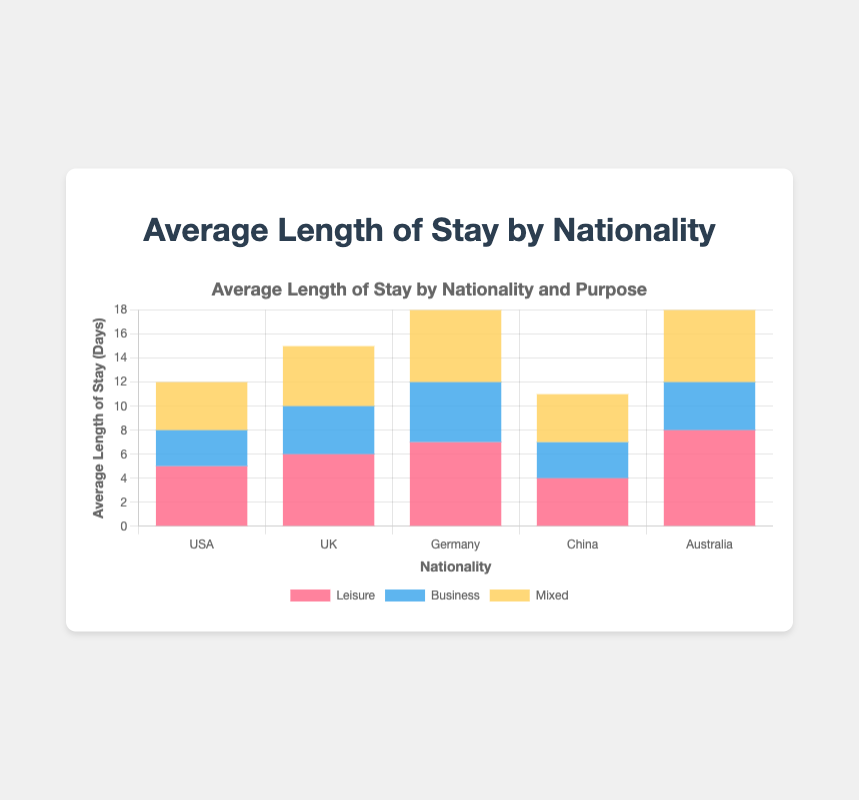What is the average length of stay for leisure purposes across all nationalities? Sum the leisure lengths for all nationalities: (5+6+7+4+8) = 30, then divide by the number of nationalities: 30/5 = 6
Answer: 6 Which nationality has the highest average length of stay for business purposes? Identify the heights of the blue bars representing business purposes; Germany has the highest value at 5 days
Answer: Germany Which nationality has the lowest average length of stay for mixed purposes? Identify the heights of the yellow bars representing mixed purposes; USA and China both have the lowest at 4 days
Answer: USA and China How much longer is the average length of stay for leisure compared to business for Australian tourists? Subtract Australia's business length (4 days) from leisure length (8 days): 8 - 4 = 4
Answer: 4 Adding the average lengths of stay for all purposes, which nationality has the longest total stay? Sum the stays for each nationality: 
- USA: 5+3+4 = 12
- UK: 6+4+5 = 15
- Germany: 7+5+6 = 18
- China: 4+3+4 = 11
- Australia: 8+4+6 = 18
Germany and Australia both have the longest total stays at 18 days
Answer: Germany and Australia What is the difference in average length of stay between leisure and mixed purposes for German tourists? Subtract Germany's mixed length (6 days) from leisure length (7 days): 7 - 6 = 1
Answer: 1 Which nationality has the same average length of stay for both leisure and mixed purposes? Compare the heights of the red and yellow bars for each nationality; USA and China both have the same (5 days and 4 days respectively)
Answer: USA and China On average, how many days do UK tourists stay for non-business purposes? Sum the leisure and mixed stays for UK (6+5): 6 + 5 = 11
Answer: 11 